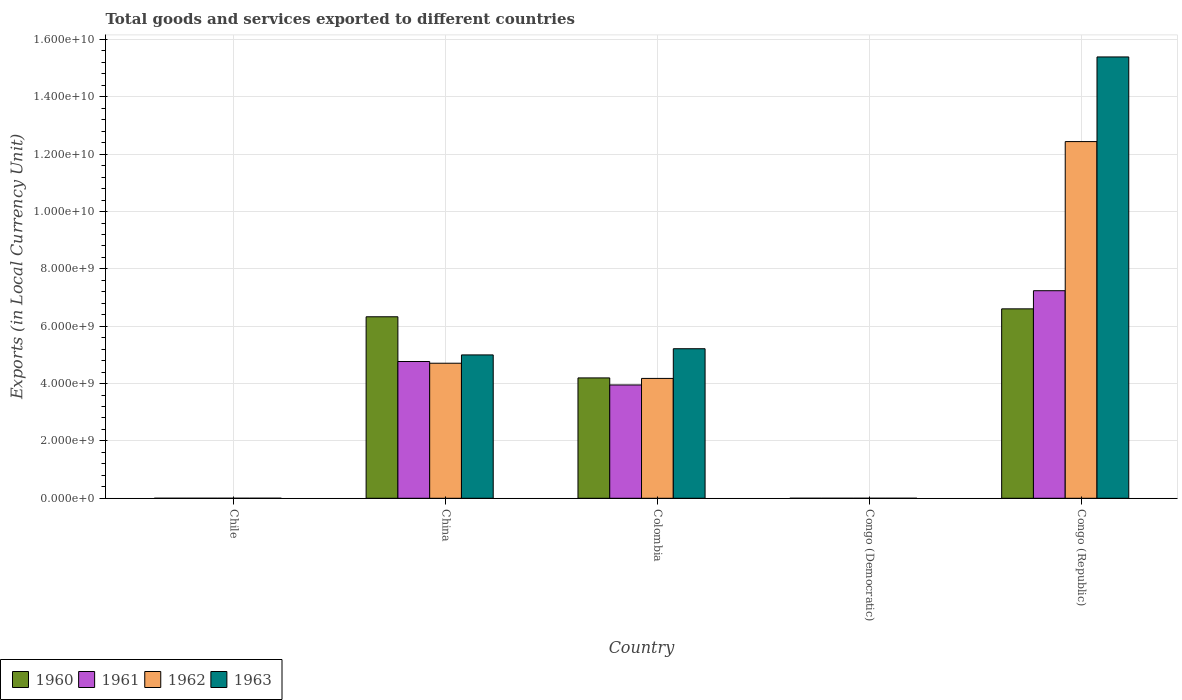Are the number of bars on each tick of the X-axis equal?
Provide a short and direct response. Yes. How many bars are there on the 2nd tick from the left?
Your answer should be compact. 4. What is the Amount of goods and services exports in 1963 in Congo (Republic)?
Make the answer very short. 1.54e+1. Across all countries, what is the maximum Amount of goods and services exports in 1961?
Offer a terse response. 7.24e+09. Across all countries, what is the minimum Amount of goods and services exports in 1962?
Make the answer very short. 6.15126409684308e-5. In which country was the Amount of goods and services exports in 1960 maximum?
Provide a short and direct response. Congo (Republic). In which country was the Amount of goods and services exports in 1963 minimum?
Ensure brevity in your answer.  Congo (Democratic). What is the total Amount of goods and services exports in 1960 in the graph?
Ensure brevity in your answer.  1.71e+1. What is the difference between the Amount of goods and services exports in 1960 in Chile and that in China?
Ensure brevity in your answer.  -6.33e+09. What is the difference between the Amount of goods and services exports in 1963 in Congo (Republic) and the Amount of goods and services exports in 1962 in China?
Offer a terse response. 1.07e+1. What is the average Amount of goods and services exports in 1961 per country?
Provide a short and direct response. 3.19e+09. What is the difference between the Amount of goods and services exports of/in 1962 and Amount of goods and services exports of/in 1963 in Congo (Democratic)?
Your answer should be very brief. -0. What is the ratio of the Amount of goods and services exports in 1962 in Chile to that in Congo (Democratic)?
Offer a very short reply. 1.14e+1. What is the difference between the highest and the second highest Amount of goods and services exports in 1961?
Offer a very short reply. 3.29e+09. What is the difference between the highest and the lowest Amount of goods and services exports in 1962?
Your answer should be compact. 1.24e+1. In how many countries, is the Amount of goods and services exports in 1962 greater than the average Amount of goods and services exports in 1962 taken over all countries?
Give a very brief answer. 2. Is the sum of the Amount of goods and services exports in 1962 in China and Colombia greater than the maximum Amount of goods and services exports in 1961 across all countries?
Keep it short and to the point. Yes. How many bars are there?
Your answer should be very brief. 20. Does the graph contain grids?
Provide a succinct answer. Yes. Where does the legend appear in the graph?
Your answer should be compact. Bottom left. How are the legend labels stacked?
Keep it short and to the point. Horizontal. What is the title of the graph?
Your answer should be compact. Total goods and services exported to different countries. What is the label or title of the Y-axis?
Your answer should be very brief. Exports (in Local Currency Unit). What is the Exports (in Local Currency Unit) of 1960 in Chile?
Provide a succinct answer. 6.00e+05. What is the Exports (in Local Currency Unit) of 1963 in Chile?
Your response must be concise. 1.10e+06. What is the Exports (in Local Currency Unit) of 1960 in China?
Give a very brief answer. 6.33e+09. What is the Exports (in Local Currency Unit) of 1961 in China?
Keep it short and to the point. 4.77e+09. What is the Exports (in Local Currency Unit) of 1962 in China?
Your answer should be very brief. 4.71e+09. What is the Exports (in Local Currency Unit) in 1960 in Colombia?
Your answer should be compact. 4.20e+09. What is the Exports (in Local Currency Unit) in 1961 in Colombia?
Provide a succinct answer. 3.95e+09. What is the Exports (in Local Currency Unit) in 1962 in Colombia?
Ensure brevity in your answer.  4.18e+09. What is the Exports (in Local Currency Unit) of 1963 in Colombia?
Your answer should be very brief. 5.22e+09. What is the Exports (in Local Currency Unit) in 1960 in Congo (Democratic)?
Keep it short and to the point. 0. What is the Exports (in Local Currency Unit) of 1961 in Congo (Democratic)?
Make the answer very short. 5.32500016561244e-5. What is the Exports (in Local Currency Unit) in 1962 in Congo (Democratic)?
Make the answer very short. 6.15126409684308e-5. What is the Exports (in Local Currency Unit) of 1963 in Congo (Democratic)?
Ensure brevity in your answer.  0. What is the Exports (in Local Currency Unit) of 1960 in Congo (Republic)?
Your answer should be very brief. 6.61e+09. What is the Exports (in Local Currency Unit) of 1961 in Congo (Republic)?
Make the answer very short. 7.24e+09. What is the Exports (in Local Currency Unit) in 1962 in Congo (Republic)?
Your answer should be compact. 1.24e+1. What is the Exports (in Local Currency Unit) in 1963 in Congo (Republic)?
Give a very brief answer. 1.54e+1. Across all countries, what is the maximum Exports (in Local Currency Unit) of 1960?
Provide a short and direct response. 6.61e+09. Across all countries, what is the maximum Exports (in Local Currency Unit) of 1961?
Your answer should be compact. 7.24e+09. Across all countries, what is the maximum Exports (in Local Currency Unit) of 1962?
Ensure brevity in your answer.  1.24e+1. Across all countries, what is the maximum Exports (in Local Currency Unit) in 1963?
Make the answer very short. 1.54e+1. Across all countries, what is the minimum Exports (in Local Currency Unit) of 1960?
Keep it short and to the point. 0. Across all countries, what is the minimum Exports (in Local Currency Unit) in 1961?
Provide a short and direct response. 5.32500016561244e-5. Across all countries, what is the minimum Exports (in Local Currency Unit) in 1962?
Make the answer very short. 6.15126409684308e-5. Across all countries, what is the minimum Exports (in Local Currency Unit) of 1963?
Offer a very short reply. 0. What is the total Exports (in Local Currency Unit) in 1960 in the graph?
Give a very brief answer. 1.71e+1. What is the total Exports (in Local Currency Unit) of 1961 in the graph?
Keep it short and to the point. 1.60e+1. What is the total Exports (in Local Currency Unit) in 1962 in the graph?
Your response must be concise. 2.13e+1. What is the total Exports (in Local Currency Unit) in 1963 in the graph?
Provide a succinct answer. 2.56e+1. What is the difference between the Exports (in Local Currency Unit) of 1960 in Chile and that in China?
Ensure brevity in your answer.  -6.33e+09. What is the difference between the Exports (in Local Currency Unit) in 1961 in Chile and that in China?
Offer a terse response. -4.77e+09. What is the difference between the Exports (in Local Currency Unit) in 1962 in Chile and that in China?
Your response must be concise. -4.71e+09. What is the difference between the Exports (in Local Currency Unit) of 1963 in Chile and that in China?
Offer a terse response. -5.00e+09. What is the difference between the Exports (in Local Currency Unit) of 1960 in Chile and that in Colombia?
Provide a succinct answer. -4.20e+09. What is the difference between the Exports (in Local Currency Unit) in 1961 in Chile and that in Colombia?
Your answer should be very brief. -3.95e+09. What is the difference between the Exports (in Local Currency Unit) of 1962 in Chile and that in Colombia?
Provide a succinct answer. -4.18e+09. What is the difference between the Exports (in Local Currency Unit) of 1963 in Chile and that in Colombia?
Ensure brevity in your answer.  -5.21e+09. What is the difference between the Exports (in Local Currency Unit) in 1960 in Chile and that in Congo (Democratic)?
Provide a short and direct response. 6.00e+05. What is the difference between the Exports (in Local Currency Unit) of 1961 in Chile and that in Congo (Democratic)?
Your response must be concise. 6.00e+05. What is the difference between the Exports (in Local Currency Unit) in 1962 in Chile and that in Congo (Democratic)?
Offer a very short reply. 7.00e+05. What is the difference between the Exports (in Local Currency Unit) in 1963 in Chile and that in Congo (Democratic)?
Provide a succinct answer. 1.10e+06. What is the difference between the Exports (in Local Currency Unit) of 1960 in Chile and that in Congo (Republic)?
Provide a short and direct response. -6.61e+09. What is the difference between the Exports (in Local Currency Unit) of 1961 in Chile and that in Congo (Republic)?
Offer a very short reply. -7.24e+09. What is the difference between the Exports (in Local Currency Unit) in 1962 in Chile and that in Congo (Republic)?
Keep it short and to the point. -1.24e+1. What is the difference between the Exports (in Local Currency Unit) in 1963 in Chile and that in Congo (Republic)?
Offer a terse response. -1.54e+1. What is the difference between the Exports (in Local Currency Unit) of 1960 in China and that in Colombia?
Your response must be concise. 2.13e+09. What is the difference between the Exports (in Local Currency Unit) in 1961 in China and that in Colombia?
Keep it short and to the point. 8.18e+08. What is the difference between the Exports (in Local Currency Unit) of 1962 in China and that in Colombia?
Offer a terse response. 5.30e+08. What is the difference between the Exports (in Local Currency Unit) of 1963 in China and that in Colombia?
Your answer should be compact. -2.16e+08. What is the difference between the Exports (in Local Currency Unit) of 1960 in China and that in Congo (Democratic)?
Ensure brevity in your answer.  6.33e+09. What is the difference between the Exports (in Local Currency Unit) of 1961 in China and that in Congo (Democratic)?
Ensure brevity in your answer.  4.77e+09. What is the difference between the Exports (in Local Currency Unit) in 1962 in China and that in Congo (Democratic)?
Your answer should be compact. 4.71e+09. What is the difference between the Exports (in Local Currency Unit) of 1963 in China and that in Congo (Democratic)?
Your answer should be compact. 5.00e+09. What is the difference between the Exports (in Local Currency Unit) in 1960 in China and that in Congo (Republic)?
Your answer should be compact. -2.76e+08. What is the difference between the Exports (in Local Currency Unit) of 1961 in China and that in Congo (Republic)?
Your response must be concise. -2.47e+09. What is the difference between the Exports (in Local Currency Unit) in 1962 in China and that in Congo (Republic)?
Your response must be concise. -7.73e+09. What is the difference between the Exports (in Local Currency Unit) of 1963 in China and that in Congo (Republic)?
Give a very brief answer. -1.04e+1. What is the difference between the Exports (in Local Currency Unit) of 1960 in Colombia and that in Congo (Democratic)?
Keep it short and to the point. 4.20e+09. What is the difference between the Exports (in Local Currency Unit) in 1961 in Colombia and that in Congo (Democratic)?
Your response must be concise. 3.95e+09. What is the difference between the Exports (in Local Currency Unit) of 1962 in Colombia and that in Congo (Democratic)?
Your answer should be compact. 4.18e+09. What is the difference between the Exports (in Local Currency Unit) in 1963 in Colombia and that in Congo (Democratic)?
Give a very brief answer. 5.22e+09. What is the difference between the Exports (in Local Currency Unit) in 1960 in Colombia and that in Congo (Republic)?
Your answer should be very brief. -2.41e+09. What is the difference between the Exports (in Local Currency Unit) in 1961 in Colombia and that in Congo (Republic)?
Your answer should be very brief. -3.29e+09. What is the difference between the Exports (in Local Currency Unit) in 1962 in Colombia and that in Congo (Republic)?
Provide a succinct answer. -8.26e+09. What is the difference between the Exports (in Local Currency Unit) of 1963 in Colombia and that in Congo (Republic)?
Give a very brief answer. -1.02e+1. What is the difference between the Exports (in Local Currency Unit) in 1960 in Congo (Democratic) and that in Congo (Republic)?
Ensure brevity in your answer.  -6.61e+09. What is the difference between the Exports (in Local Currency Unit) in 1961 in Congo (Democratic) and that in Congo (Republic)?
Your answer should be compact. -7.24e+09. What is the difference between the Exports (in Local Currency Unit) in 1962 in Congo (Democratic) and that in Congo (Republic)?
Your response must be concise. -1.24e+1. What is the difference between the Exports (in Local Currency Unit) of 1963 in Congo (Democratic) and that in Congo (Republic)?
Keep it short and to the point. -1.54e+1. What is the difference between the Exports (in Local Currency Unit) of 1960 in Chile and the Exports (in Local Currency Unit) of 1961 in China?
Offer a terse response. -4.77e+09. What is the difference between the Exports (in Local Currency Unit) of 1960 in Chile and the Exports (in Local Currency Unit) of 1962 in China?
Your answer should be compact. -4.71e+09. What is the difference between the Exports (in Local Currency Unit) of 1960 in Chile and the Exports (in Local Currency Unit) of 1963 in China?
Your response must be concise. -5.00e+09. What is the difference between the Exports (in Local Currency Unit) of 1961 in Chile and the Exports (in Local Currency Unit) of 1962 in China?
Your answer should be very brief. -4.71e+09. What is the difference between the Exports (in Local Currency Unit) in 1961 in Chile and the Exports (in Local Currency Unit) in 1963 in China?
Offer a very short reply. -5.00e+09. What is the difference between the Exports (in Local Currency Unit) in 1962 in Chile and the Exports (in Local Currency Unit) in 1963 in China?
Your answer should be very brief. -5.00e+09. What is the difference between the Exports (in Local Currency Unit) of 1960 in Chile and the Exports (in Local Currency Unit) of 1961 in Colombia?
Offer a terse response. -3.95e+09. What is the difference between the Exports (in Local Currency Unit) in 1960 in Chile and the Exports (in Local Currency Unit) in 1962 in Colombia?
Your response must be concise. -4.18e+09. What is the difference between the Exports (in Local Currency Unit) in 1960 in Chile and the Exports (in Local Currency Unit) in 1963 in Colombia?
Make the answer very short. -5.21e+09. What is the difference between the Exports (in Local Currency Unit) in 1961 in Chile and the Exports (in Local Currency Unit) in 1962 in Colombia?
Your answer should be compact. -4.18e+09. What is the difference between the Exports (in Local Currency Unit) in 1961 in Chile and the Exports (in Local Currency Unit) in 1963 in Colombia?
Provide a short and direct response. -5.21e+09. What is the difference between the Exports (in Local Currency Unit) in 1962 in Chile and the Exports (in Local Currency Unit) in 1963 in Colombia?
Ensure brevity in your answer.  -5.21e+09. What is the difference between the Exports (in Local Currency Unit) of 1960 in Chile and the Exports (in Local Currency Unit) of 1961 in Congo (Democratic)?
Your response must be concise. 6.00e+05. What is the difference between the Exports (in Local Currency Unit) of 1960 in Chile and the Exports (in Local Currency Unit) of 1962 in Congo (Democratic)?
Keep it short and to the point. 6.00e+05. What is the difference between the Exports (in Local Currency Unit) of 1960 in Chile and the Exports (in Local Currency Unit) of 1963 in Congo (Democratic)?
Offer a very short reply. 6.00e+05. What is the difference between the Exports (in Local Currency Unit) in 1961 in Chile and the Exports (in Local Currency Unit) in 1962 in Congo (Democratic)?
Your response must be concise. 6.00e+05. What is the difference between the Exports (in Local Currency Unit) in 1961 in Chile and the Exports (in Local Currency Unit) in 1963 in Congo (Democratic)?
Ensure brevity in your answer.  6.00e+05. What is the difference between the Exports (in Local Currency Unit) of 1962 in Chile and the Exports (in Local Currency Unit) of 1963 in Congo (Democratic)?
Offer a very short reply. 7.00e+05. What is the difference between the Exports (in Local Currency Unit) in 1960 in Chile and the Exports (in Local Currency Unit) in 1961 in Congo (Republic)?
Keep it short and to the point. -7.24e+09. What is the difference between the Exports (in Local Currency Unit) of 1960 in Chile and the Exports (in Local Currency Unit) of 1962 in Congo (Republic)?
Your answer should be very brief. -1.24e+1. What is the difference between the Exports (in Local Currency Unit) in 1960 in Chile and the Exports (in Local Currency Unit) in 1963 in Congo (Republic)?
Your response must be concise. -1.54e+1. What is the difference between the Exports (in Local Currency Unit) in 1961 in Chile and the Exports (in Local Currency Unit) in 1962 in Congo (Republic)?
Give a very brief answer. -1.24e+1. What is the difference between the Exports (in Local Currency Unit) in 1961 in Chile and the Exports (in Local Currency Unit) in 1963 in Congo (Republic)?
Make the answer very short. -1.54e+1. What is the difference between the Exports (in Local Currency Unit) of 1962 in Chile and the Exports (in Local Currency Unit) of 1963 in Congo (Republic)?
Provide a short and direct response. -1.54e+1. What is the difference between the Exports (in Local Currency Unit) in 1960 in China and the Exports (in Local Currency Unit) in 1961 in Colombia?
Offer a terse response. 2.38e+09. What is the difference between the Exports (in Local Currency Unit) in 1960 in China and the Exports (in Local Currency Unit) in 1962 in Colombia?
Provide a short and direct response. 2.15e+09. What is the difference between the Exports (in Local Currency Unit) in 1960 in China and the Exports (in Local Currency Unit) in 1963 in Colombia?
Provide a short and direct response. 1.11e+09. What is the difference between the Exports (in Local Currency Unit) of 1961 in China and the Exports (in Local Currency Unit) of 1962 in Colombia?
Provide a short and direct response. 5.90e+08. What is the difference between the Exports (in Local Currency Unit) in 1961 in China and the Exports (in Local Currency Unit) in 1963 in Colombia?
Provide a succinct answer. -4.46e+08. What is the difference between the Exports (in Local Currency Unit) of 1962 in China and the Exports (in Local Currency Unit) of 1963 in Colombia?
Give a very brief answer. -5.06e+08. What is the difference between the Exports (in Local Currency Unit) in 1960 in China and the Exports (in Local Currency Unit) in 1961 in Congo (Democratic)?
Provide a succinct answer. 6.33e+09. What is the difference between the Exports (in Local Currency Unit) in 1960 in China and the Exports (in Local Currency Unit) in 1962 in Congo (Democratic)?
Your answer should be very brief. 6.33e+09. What is the difference between the Exports (in Local Currency Unit) of 1960 in China and the Exports (in Local Currency Unit) of 1963 in Congo (Democratic)?
Your response must be concise. 6.33e+09. What is the difference between the Exports (in Local Currency Unit) in 1961 in China and the Exports (in Local Currency Unit) in 1962 in Congo (Democratic)?
Your answer should be very brief. 4.77e+09. What is the difference between the Exports (in Local Currency Unit) of 1961 in China and the Exports (in Local Currency Unit) of 1963 in Congo (Democratic)?
Make the answer very short. 4.77e+09. What is the difference between the Exports (in Local Currency Unit) of 1962 in China and the Exports (in Local Currency Unit) of 1963 in Congo (Democratic)?
Your answer should be compact. 4.71e+09. What is the difference between the Exports (in Local Currency Unit) of 1960 in China and the Exports (in Local Currency Unit) of 1961 in Congo (Republic)?
Make the answer very short. -9.09e+08. What is the difference between the Exports (in Local Currency Unit) of 1960 in China and the Exports (in Local Currency Unit) of 1962 in Congo (Republic)?
Your answer should be very brief. -6.11e+09. What is the difference between the Exports (in Local Currency Unit) of 1960 in China and the Exports (in Local Currency Unit) of 1963 in Congo (Republic)?
Offer a terse response. -9.06e+09. What is the difference between the Exports (in Local Currency Unit) in 1961 in China and the Exports (in Local Currency Unit) in 1962 in Congo (Republic)?
Your answer should be compact. -7.67e+09. What is the difference between the Exports (in Local Currency Unit) in 1961 in China and the Exports (in Local Currency Unit) in 1963 in Congo (Republic)?
Your answer should be compact. -1.06e+1. What is the difference between the Exports (in Local Currency Unit) in 1962 in China and the Exports (in Local Currency Unit) in 1963 in Congo (Republic)?
Your answer should be very brief. -1.07e+1. What is the difference between the Exports (in Local Currency Unit) in 1960 in Colombia and the Exports (in Local Currency Unit) in 1961 in Congo (Democratic)?
Offer a terse response. 4.20e+09. What is the difference between the Exports (in Local Currency Unit) in 1960 in Colombia and the Exports (in Local Currency Unit) in 1962 in Congo (Democratic)?
Offer a terse response. 4.20e+09. What is the difference between the Exports (in Local Currency Unit) of 1960 in Colombia and the Exports (in Local Currency Unit) of 1963 in Congo (Democratic)?
Provide a short and direct response. 4.20e+09. What is the difference between the Exports (in Local Currency Unit) of 1961 in Colombia and the Exports (in Local Currency Unit) of 1962 in Congo (Democratic)?
Ensure brevity in your answer.  3.95e+09. What is the difference between the Exports (in Local Currency Unit) of 1961 in Colombia and the Exports (in Local Currency Unit) of 1963 in Congo (Democratic)?
Your answer should be very brief. 3.95e+09. What is the difference between the Exports (in Local Currency Unit) of 1962 in Colombia and the Exports (in Local Currency Unit) of 1963 in Congo (Democratic)?
Your answer should be compact. 4.18e+09. What is the difference between the Exports (in Local Currency Unit) in 1960 in Colombia and the Exports (in Local Currency Unit) in 1961 in Congo (Republic)?
Provide a succinct answer. -3.04e+09. What is the difference between the Exports (in Local Currency Unit) in 1960 in Colombia and the Exports (in Local Currency Unit) in 1962 in Congo (Republic)?
Your response must be concise. -8.24e+09. What is the difference between the Exports (in Local Currency Unit) of 1960 in Colombia and the Exports (in Local Currency Unit) of 1963 in Congo (Republic)?
Provide a succinct answer. -1.12e+1. What is the difference between the Exports (in Local Currency Unit) of 1961 in Colombia and the Exports (in Local Currency Unit) of 1962 in Congo (Republic)?
Your answer should be very brief. -8.49e+09. What is the difference between the Exports (in Local Currency Unit) of 1961 in Colombia and the Exports (in Local Currency Unit) of 1963 in Congo (Republic)?
Provide a short and direct response. -1.14e+1. What is the difference between the Exports (in Local Currency Unit) in 1962 in Colombia and the Exports (in Local Currency Unit) in 1963 in Congo (Republic)?
Provide a short and direct response. -1.12e+1. What is the difference between the Exports (in Local Currency Unit) in 1960 in Congo (Democratic) and the Exports (in Local Currency Unit) in 1961 in Congo (Republic)?
Ensure brevity in your answer.  -7.24e+09. What is the difference between the Exports (in Local Currency Unit) in 1960 in Congo (Democratic) and the Exports (in Local Currency Unit) in 1962 in Congo (Republic)?
Your answer should be compact. -1.24e+1. What is the difference between the Exports (in Local Currency Unit) in 1960 in Congo (Democratic) and the Exports (in Local Currency Unit) in 1963 in Congo (Republic)?
Provide a succinct answer. -1.54e+1. What is the difference between the Exports (in Local Currency Unit) of 1961 in Congo (Democratic) and the Exports (in Local Currency Unit) of 1962 in Congo (Republic)?
Your answer should be very brief. -1.24e+1. What is the difference between the Exports (in Local Currency Unit) in 1961 in Congo (Democratic) and the Exports (in Local Currency Unit) in 1963 in Congo (Republic)?
Make the answer very short. -1.54e+1. What is the difference between the Exports (in Local Currency Unit) in 1962 in Congo (Democratic) and the Exports (in Local Currency Unit) in 1963 in Congo (Republic)?
Keep it short and to the point. -1.54e+1. What is the average Exports (in Local Currency Unit) of 1960 per country?
Offer a very short reply. 3.43e+09. What is the average Exports (in Local Currency Unit) in 1961 per country?
Make the answer very short. 3.19e+09. What is the average Exports (in Local Currency Unit) in 1962 per country?
Make the answer very short. 4.27e+09. What is the average Exports (in Local Currency Unit) of 1963 per country?
Your response must be concise. 5.12e+09. What is the difference between the Exports (in Local Currency Unit) in 1960 and Exports (in Local Currency Unit) in 1963 in Chile?
Offer a terse response. -5.00e+05. What is the difference between the Exports (in Local Currency Unit) of 1961 and Exports (in Local Currency Unit) of 1963 in Chile?
Give a very brief answer. -5.00e+05. What is the difference between the Exports (in Local Currency Unit) of 1962 and Exports (in Local Currency Unit) of 1963 in Chile?
Offer a very short reply. -4.00e+05. What is the difference between the Exports (in Local Currency Unit) in 1960 and Exports (in Local Currency Unit) in 1961 in China?
Provide a succinct answer. 1.56e+09. What is the difference between the Exports (in Local Currency Unit) of 1960 and Exports (in Local Currency Unit) of 1962 in China?
Your answer should be very brief. 1.62e+09. What is the difference between the Exports (in Local Currency Unit) in 1960 and Exports (in Local Currency Unit) in 1963 in China?
Give a very brief answer. 1.33e+09. What is the difference between the Exports (in Local Currency Unit) in 1961 and Exports (in Local Currency Unit) in 1962 in China?
Make the answer very short. 6.00e+07. What is the difference between the Exports (in Local Currency Unit) of 1961 and Exports (in Local Currency Unit) of 1963 in China?
Ensure brevity in your answer.  -2.30e+08. What is the difference between the Exports (in Local Currency Unit) of 1962 and Exports (in Local Currency Unit) of 1963 in China?
Offer a very short reply. -2.90e+08. What is the difference between the Exports (in Local Currency Unit) in 1960 and Exports (in Local Currency Unit) in 1961 in Colombia?
Offer a terse response. 2.46e+08. What is the difference between the Exports (in Local Currency Unit) in 1960 and Exports (in Local Currency Unit) in 1962 in Colombia?
Keep it short and to the point. 1.74e+07. What is the difference between the Exports (in Local Currency Unit) of 1960 and Exports (in Local Currency Unit) of 1963 in Colombia?
Your answer should be compact. -1.02e+09. What is the difference between the Exports (in Local Currency Unit) of 1961 and Exports (in Local Currency Unit) of 1962 in Colombia?
Offer a terse response. -2.28e+08. What is the difference between the Exports (in Local Currency Unit) of 1961 and Exports (in Local Currency Unit) of 1963 in Colombia?
Give a very brief answer. -1.26e+09. What is the difference between the Exports (in Local Currency Unit) in 1962 and Exports (in Local Currency Unit) in 1963 in Colombia?
Provide a succinct answer. -1.04e+09. What is the difference between the Exports (in Local Currency Unit) in 1960 and Exports (in Local Currency Unit) in 1962 in Congo (Democratic)?
Your answer should be compact. 0. What is the difference between the Exports (in Local Currency Unit) in 1960 and Exports (in Local Currency Unit) in 1963 in Congo (Democratic)?
Offer a very short reply. -0. What is the difference between the Exports (in Local Currency Unit) of 1961 and Exports (in Local Currency Unit) of 1963 in Congo (Democratic)?
Ensure brevity in your answer.  -0. What is the difference between the Exports (in Local Currency Unit) in 1962 and Exports (in Local Currency Unit) in 1963 in Congo (Democratic)?
Give a very brief answer. -0. What is the difference between the Exports (in Local Currency Unit) of 1960 and Exports (in Local Currency Unit) of 1961 in Congo (Republic)?
Make the answer very short. -6.33e+08. What is the difference between the Exports (in Local Currency Unit) in 1960 and Exports (in Local Currency Unit) in 1962 in Congo (Republic)?
Ensure brevity in your answer.  -5.83e+09. What is the difference between the Exports (in Local Currency Unit) of 1960 and Exports (in Local Currency Unit) of 1963 in Congo (Republic)?
Offer a terse response. -8.79e+09. What is the difference between the Exports (in Local Currency Unit) in 1961 and Exports (in Local Currency Unit) in 1962 in Congo (Republic)?
Make the answer very short. -5.20e+09. What is the difference between the Exports (in Local Currency Unit) of 1961 and Exports (in Local Currency Unit) of 1963 in Congo (Republic)?
Provide a succinct answer. -8.15e+09. What is the difference between the Exports (in Local Currency Unit) of 1962 and Exports (in Local Currency Unit) of 1963 in Congo (Republic)?
Offer a terse response. -2.95e+09. What is the ratio of the Exports (in Local Currency Unit) of 1960 in Chile to that in China?
Offer a very short reply. 0. What is the ratio of the Exports (in Local Currency Unit) of 1963 in Chile to that in China?
Your response must be concise. 0. What is the ratio of the Exports (in Local Currency Unit) in 1960 in Chile to that in Colombia?
Ensure brevity in your answer.  0. What is the ratio of the Exports (in Local Currency Unit) of 1962 in Chile to that in Colombia?
Your answer should be very brief. 0. What is the ratio of the Exports (in Local Currency Unit) of 1963 in Chile to that in Colombia?
Your answer should be compact. 0. What is the ratio of the Exports (in Local Currency Unit) of 1960 in Chile to that in Congo (Democratic)?
Ensure brevity in your answer.  5.55e+09. What is the ratio of the Exports (in Local Currency Unit) in 1961 in Chile to that in Congo (Democratic)?
Provide a short and direct response. 1.13e+1. What is the ratio of the Exports (in Local Currency Unit) in 1962 in Chile to that in Congo (Democratic)?
Your answer should be compact. 1.14e+1. What is the ratio of the Exports (in Local Currency Unit) of 1963 in Chile to that in Congo (Democratic)?
Provide a short and direct response. 2.21e+09. What is the ratio of the Exports (in Local Currency Unit) of 1963 in Chile to that in Congo (Republic)?
Make the answer very short. 0. What is the ratio of the Exports (in Local Currency Unit) of 1960 in China to that in Colombia?
Ensure brevity in your answer.  1.51. What is the ratio of the Exports (in Local Currency Unit) of 1961 in China to that in Colombia?
Provide a succinct answer. 1.21. What is the ratio of the Exports (in Local Currency Unit) in 1962 in China to that in Colombia?
Ensure brevity in your answer.  1.13. What is the ratio of the Exports (in Local Currency Unit) in 1963 in China to that in Colombia?
Your answer should be compact. 0.96. What is the ratio of the Exports (in Local Currency Unit) in 1960 in China to that in Congo (Democratic)?
Your response must be concise. 5.86e+13. What is the ratio of the Exports (in Local Currency Unit) of 1961 in China to that in Congo (Democratic)?
Provide a short and direct response. 8.96e+13. What is the ratio of the Exports (in Local Currency Unit) in 1962 in China to that in Congo (Democratic)?
Offer a very short reply. 7.66e+13. What is the ratio of the Exports (in Local Currency Unit) in 1963 in China to that in Congo (Democratic)?
Ensure brevity in your answer.  1.00e+13. What is the ratio of the Exports (in Local Currency Unit) of 1960 in China to that in Congo (Republic)?
Ensure brevity in your answer.  0.96. What is the ratio of the Exports (in Local Currency Unit) in 1961 in China to that in Congo (Republic)?
Offer a terse response. 0.66. What is the ratio of the Exports (in Local Currency Unit) in 1962 in China to that in Congo (Republic)?
Offer a very short reply. 0.38. What is the ratio of the Exports (in Local Currency Unit) in 1963 in China to that in Congo (Republic)?
Your response must be concise. 0.32. What is the ratio of the Exports (in Local Currency Unit) in 1960 in Colombia to that in Congo (Democratic)?
Give a very brief answer. 3.89e+13. What is the ratio of the Exports (in Local Currency Unit) of 1961 in Colombia to that in Congo (Democratic)?
Keep it short and to the point. 7.42e+13. What is the ratio of the Exports (in Local Currency Unit) of 1962 in Colombia to that in Congo (Democratic)?
Your response must be concise. 6.80e+13. What is the ratio of the Exports (in Local Currency Unit) of 1963 in Colombia to that in Congo (Democratic)?
Make the answer very short. 1.05e+13. What is the ratio of the Exports (in Local Currency Unit) in 1960 in Colombia to that in Congo (Republic)?
Your answer should be very brief. 0.64. What is the ratio of the Exports (in Local Currency Unit) of 1961 in Colombia to that in Congo (Republic)?
Give a very brief answer. 0.55. What is the ratio of the Exports (in Local Currency Unit) of 1962 in Colombia to that in Congo (Republic)?
Offer a very short reply. 0.34. What is the ratio of the Exports (in Local Currency Unit) in 1963 in Colombia to that in Congo (Republic)?
Offer a terse response. 0.34. What is the ratio of the Exports (in Local Currency Unit) in 1960 in Congo (Democratic) to that in Congo (Republic)?
Your answer should be very brief. 0. What is the ratio of the Exports (in Local Currency Unit) of 1962 in Congo (Democratic) to that in Congo (Republic)?
Offer a terse response. 0. What is the ratio of the Exports (in Local Currency Unit) of 1963 in Congo (Democratic) to that in Congo (Republic)?
Offer a terse response. 0. What is the difference between the highest and the second highest Exports (in Local Currency Unit) of 1960?
Offer a very short reply. 2.76e+08. What is the difference between the highest and the second highest Exports (in Local Currency Unit) of 1961?
Keep it short and to the point. 2.47e+09. What is the difference between the highest and the second highest Exports (in Local Currency Unit) in 1962?
Keep it short and to the point. 7.73e+09. What is the difference between the highest and the second highest Exports (in Local Currency Unit) of 1963?
Make the answer very short. 1.02e+1. What is the difference between the highest and the lowest Exports (in Local Currency Unit) in 1960?
Keep it short and to the point. 6.61e+09. What is the difference between the highest and the lowest Exports (in Local Currency Unit) in 1961?
Provide a short and direct response. 7.24e+09. What is the difference between the highest and the lowest Exports (in Local Currency Unit) in 1962?
Ensure brevity in your answer.  1.24e+1. What is the difference between the highest and the lowest Exports (in Local Currency Unit) of 1963?
Your response must be concise. 1.54e+1. 